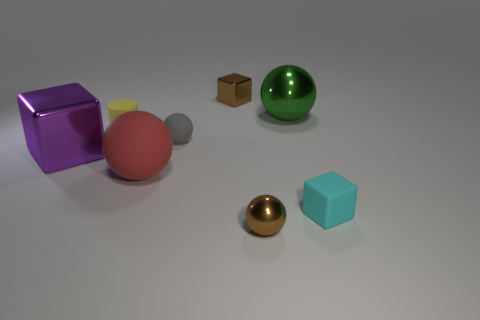Do the tiny metallic cube and the tiny shiny sphere have the same color?
Make the answer very short. Yes. What number of purple cubes have the same size as the red rubber sphere?
Give a very brief answer. 1. What is the material of the cyan object that is the same shape as the purple shiny object?
Your answer should be very brief. Rubber. Does the big rubber object have the same shape as the small cyan object?
Your answer should be compact. No. What number of small brown metallic objects are behind the yellow matte cylinder?
Your answer should be compact. 1. There is a tiny shiny object in front of the tiny block in front of the tiny yellow thing; what is its shape?
Make the answer very short. Sphere. There is a large red thing that is the same material as the tiny gray thing; what shape is it?
Your answer should be compact. Sphere. Does the metallic ball in front of the big green sphere have the same size as the metallic sphere that is behind the red ball?
Your response must be concise. No. What shape is the small brown object that is behind the tiny gray object?
Offer a terse response. Cube. What color is the large shiny ball?
Offer a terse response. Green. 